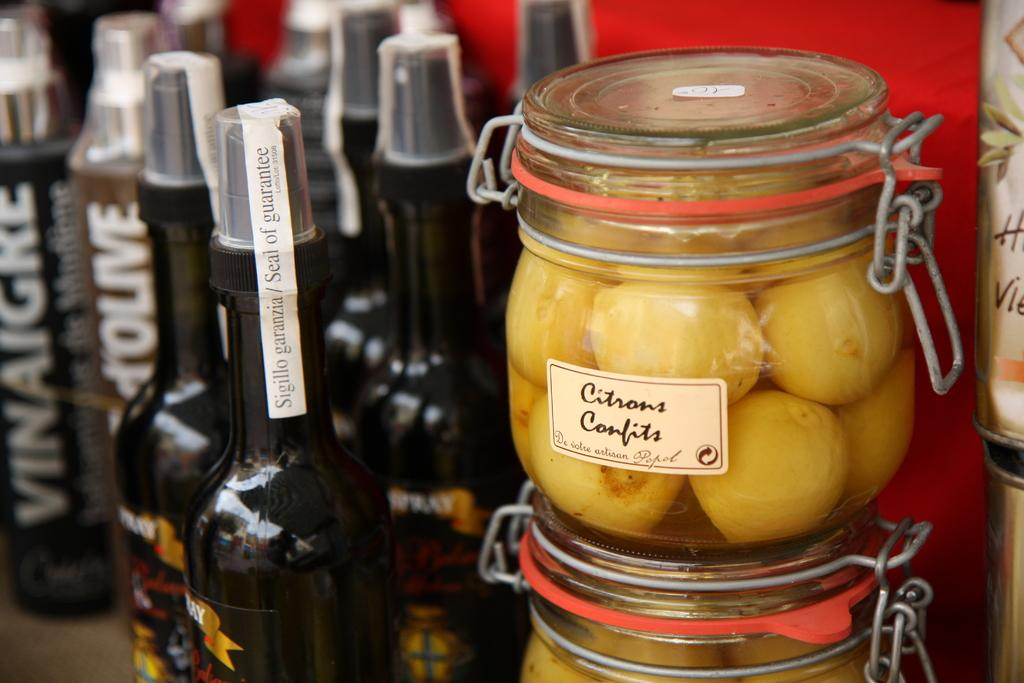What type of containers can be seen in the image? There are black bottles and jars in the image. What is inside the containers? The bottles and jars have something inside them. What type of machine is visible in the image? There is no machine present in the image; it only features black bottles and jars. How does the grip of the jars affect their contents? The grip of the jars is not mentioned in the image, and therefore its effect on the contents cannot be determined. 